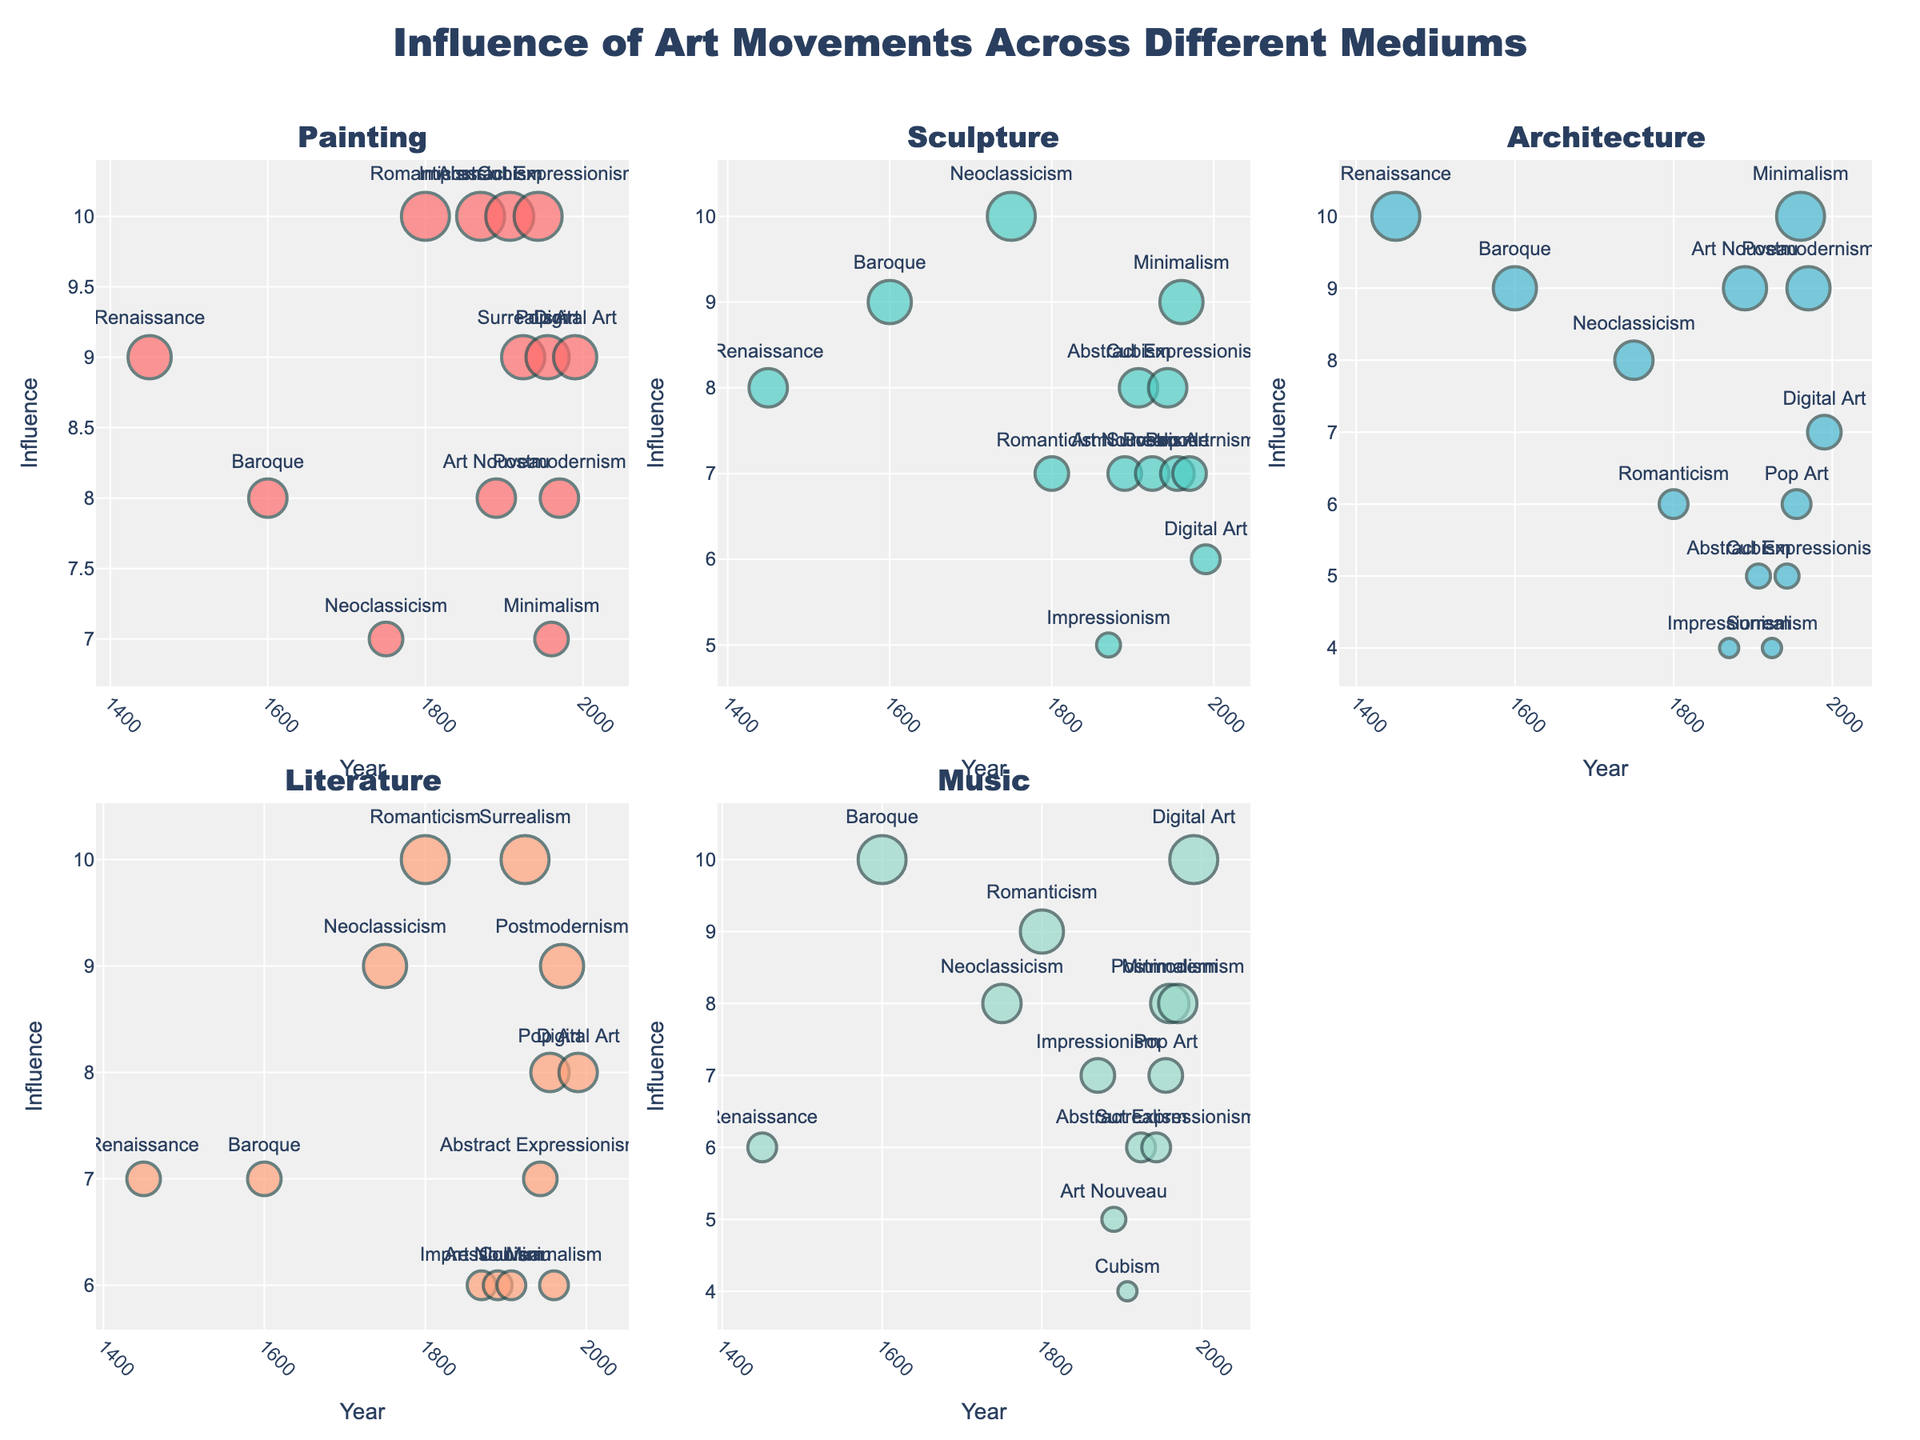what is the influence of Renaissance on Painting? The influence of Renaissance on Painting is indicated by the position of the Renaissance data point in the Painting subplot, which has an influence value of 9.
Answer: 9 Which art movement has the highest influence on Music? By examining the Music subplot, the Digital Art movement data point is positioned highest, indicating an influence value of 10.
Answer: Digital Art Which medium shows the lowest influence value for Surrealism? In the Surrealism subplot, the data points show the lowest influence value of 4 for Architecture.
Answer: Architecture How does the influence of Impressionism on Sculpture compare to its influence on Painting? The Sculpture subplot shows the influence value for Impressionism is 5, and the Painting subplot shows it is 10. Thus, Impressionism has a higher influence on Painting compared to Sculpture.
Answer: Higher on Painting What's the average influence of Baroque across all mediums? The influence values for Baroque are: Painting (8), Sculpture (9), Architecture (9), Literature (7), and Music (10). The average is calculated as (8+9+9+7+10)/5 = 8.6.
Answer: 8.6 Which art movement shows a uniform influence of 7 on all mediums? By checking all subplots, it is evident that no art movement shows a uniform influence value of 7 across all mediums.
Answer: None Between Renaissance and Neoclassicism, which has a greater average influence across Literature and Architecture? Renaissance shows influences of Literature (7), Architecture (10), and Neoclassicism shows Literature (9), Architecture (8). Averages: 
Renaissance: (7+10)/2 = 8.5 
Neoclassicism: (9+8)/2 = 8.5 
Both have the same average influence.
Answer: Both have the same What is the time period range of the art movements shown in the figure? The x-axis in different subplots reveals the years of the earliest (1450 for Renaissance) and latest (1990 for Digital Art) art movements. The range is 1450 to 1990.
Answer: 1450 to 1990 